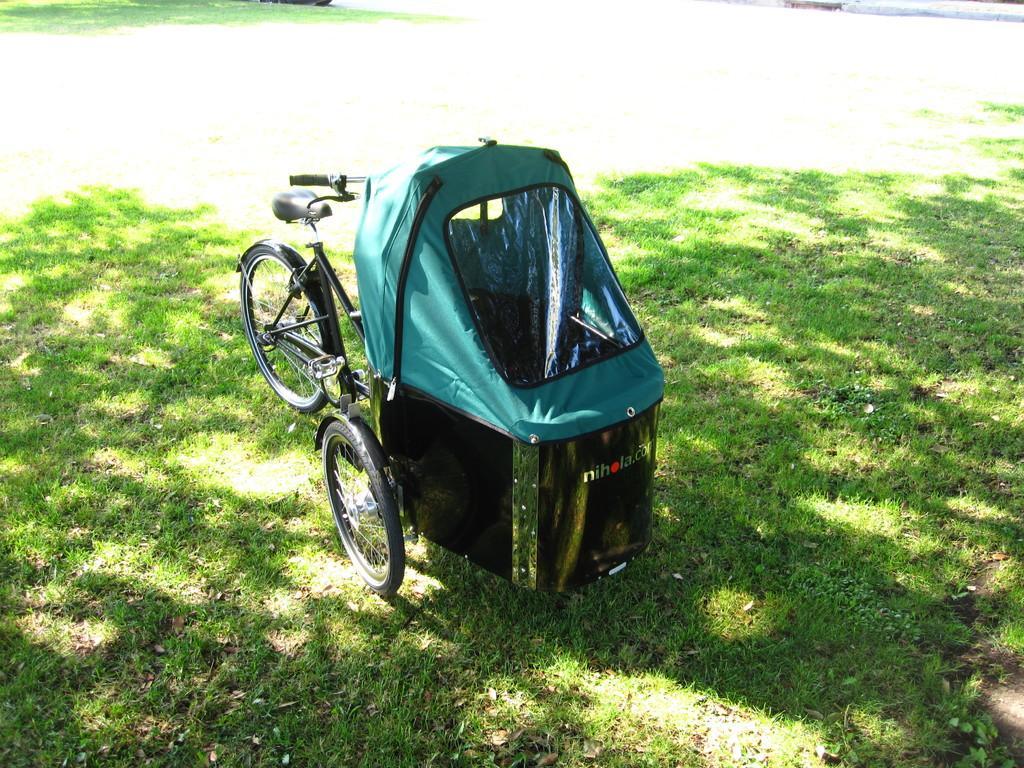How would you summarize this image in a sentence or two? In the center of the image, we can see a trolley on the ground. 